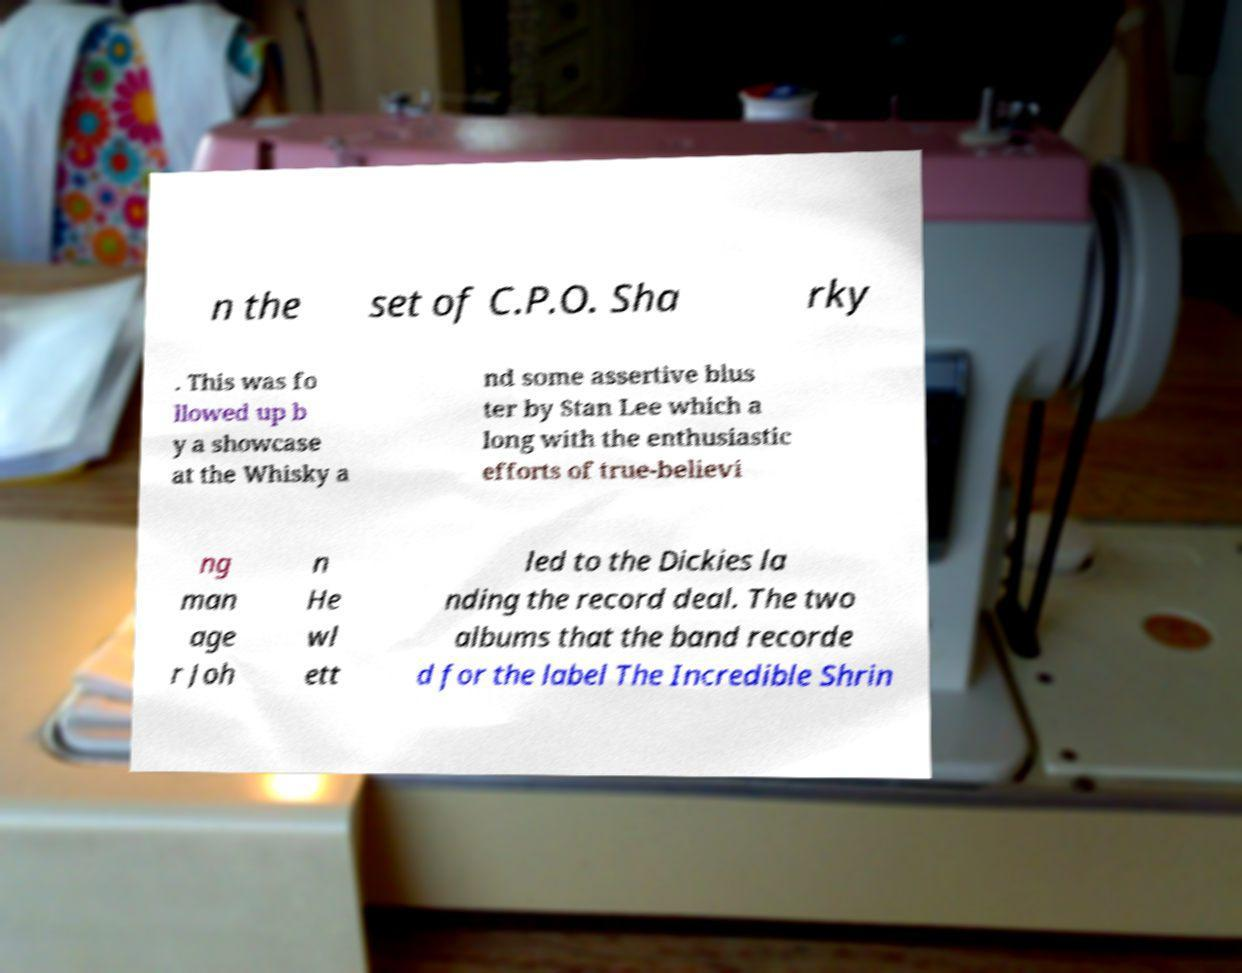I need the written content from this picture converted into text. Can you do that? n the set of C.P.O. Sha rky . This was fo llowed up b y a showcase at the Whisky a nd some assertive blus ter by Stan Lee which a long with the enthusiastic efforts of true-believi ng man age r Joh n He wl ett led to the Dickies la nding the record deal. The two albums that the band recorde d for the label The Incredible Shrin 